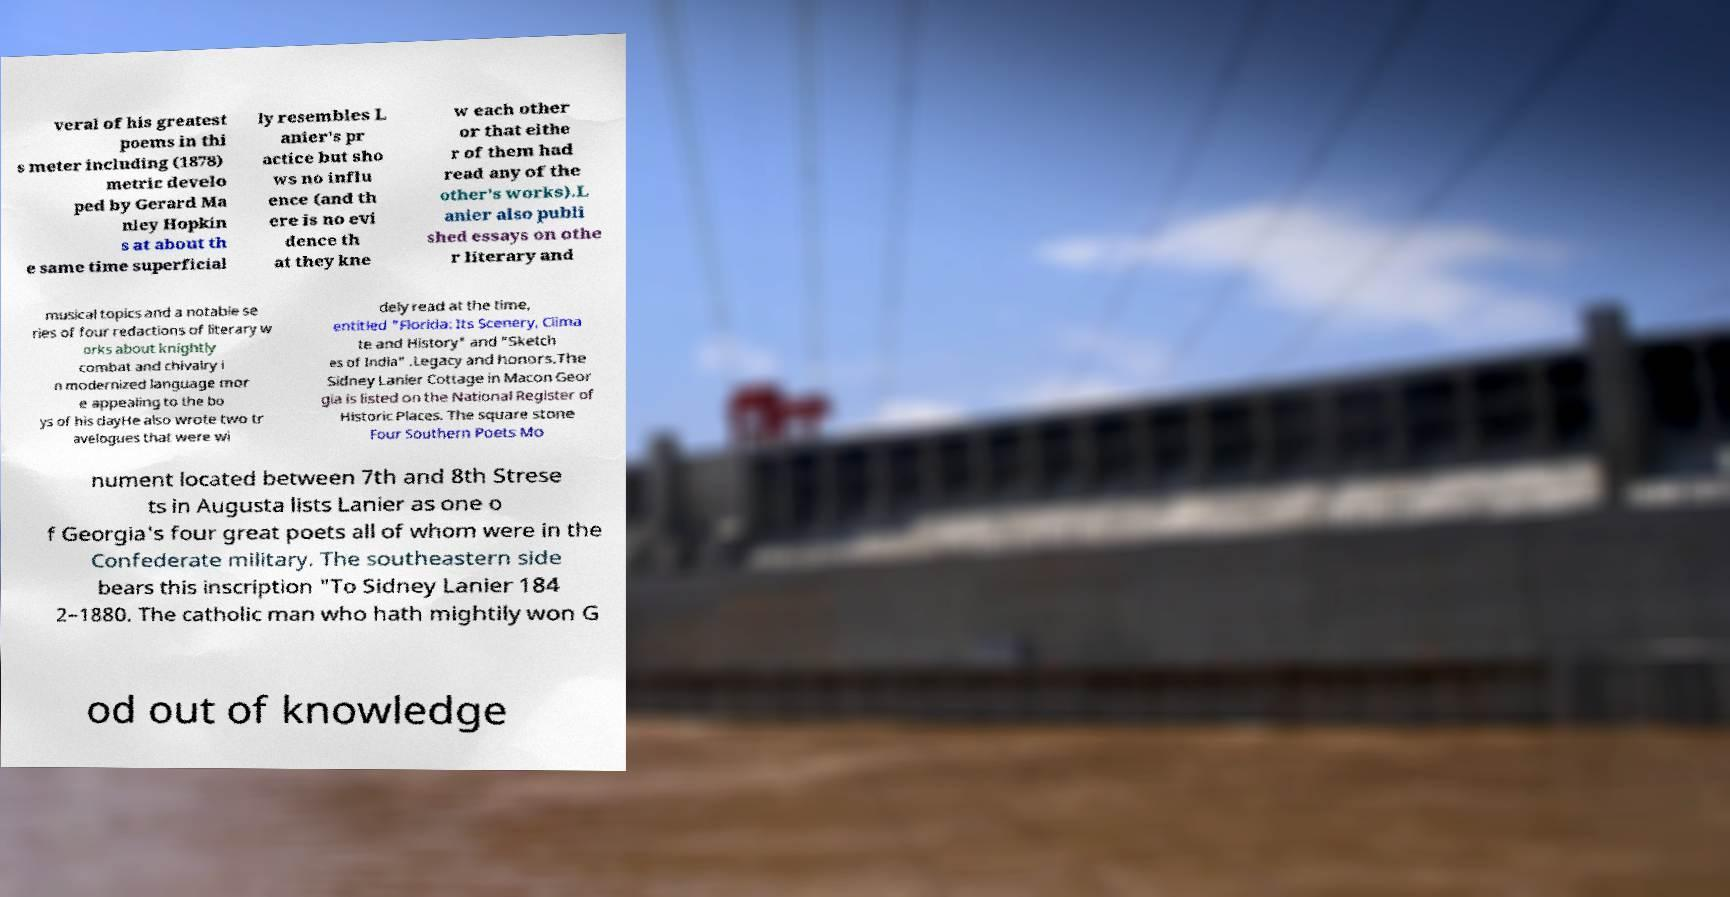Could you extract and type out the text from this image? veral of his greatest poems in thi s meter including (1878) metric develo ped by Gerard Ma nley Hopkin s at about th e same time superficial ly resembles L anier's pr actice but sho ws no influ ence (and th ere is no evi dence th at they kne w each other or that eithe r of them had read any of the other's works).L anier also publi shed essays on othe r literary and musical topics and a notable se ries of four redactions of literary w orks about knightly combat and chivalry i n modernized language mor e appealing to the bo ys of his dayHe also wrote two tr avelogues that were wi dely read at the time, entitled "Florida: Its Scenery, Clima te and History" and "Sketch es of India" .Legacy and honors.The Sidney Lanier Cottage in Macon Geor gia is listed on the National Register of Historic Places. The square stone Four Southern Poets Mo nument located between 7th and 8th Strese ts in Augusta lists Lanier as one o f Georgia's four great poets all of whom were in the Confederate military. The southeastern side bears this inscription "To Sidney Lanier 184 2–1880. The catholic man who hath mightily won G od out of knowledge 